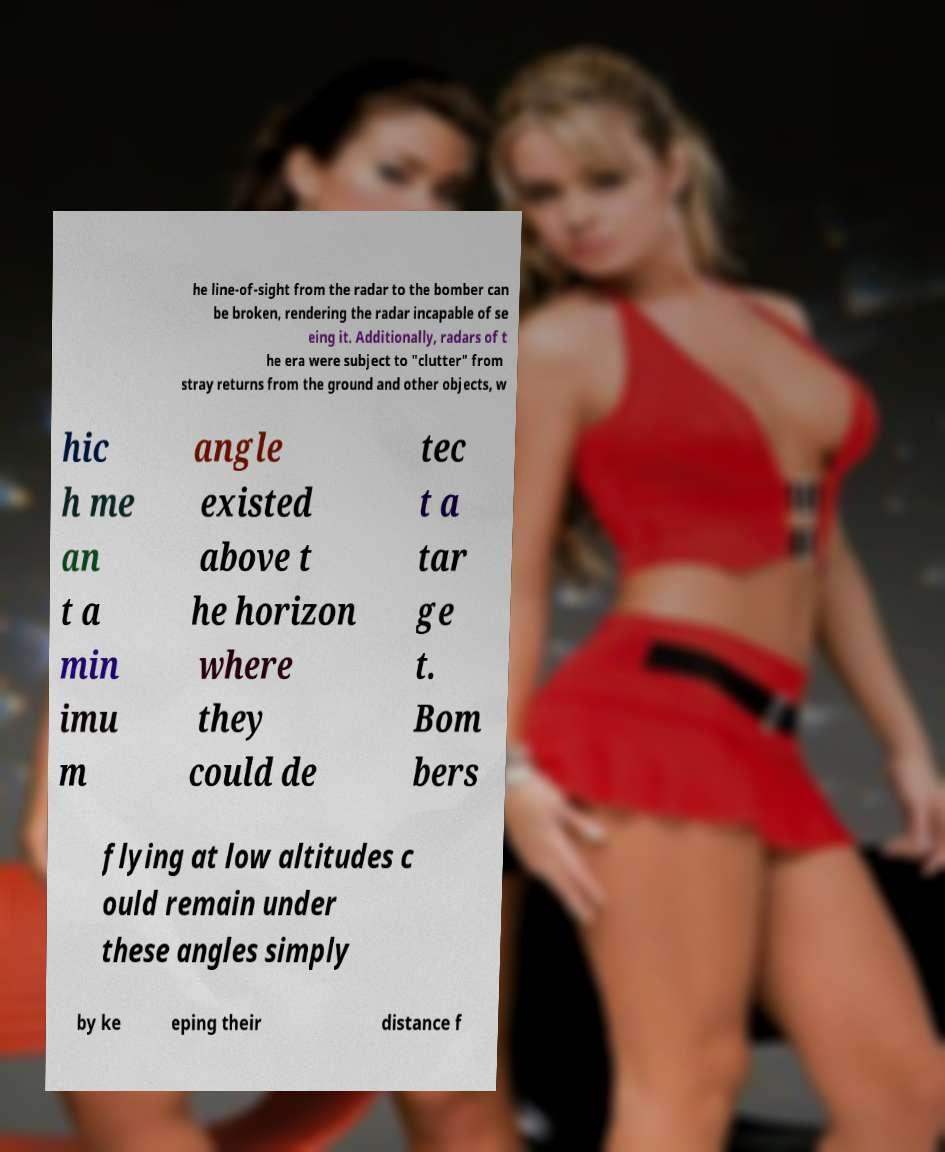For documentation purposes, I need the text within this image transcribed. Could you provide that? he line-of-sight from the radar to the bomber can be broken, rendering the radar incapable of se eing it. Additionally, radars of t he era were subject to "clutter" from stray returns from the ground and other objects, w hic h me an t a min imu m angle existed above t he horizon where they could de tec t a tar ge t. Bom bers flying at low altitudes c ould remain under these angles simply by ke eping their distance f 